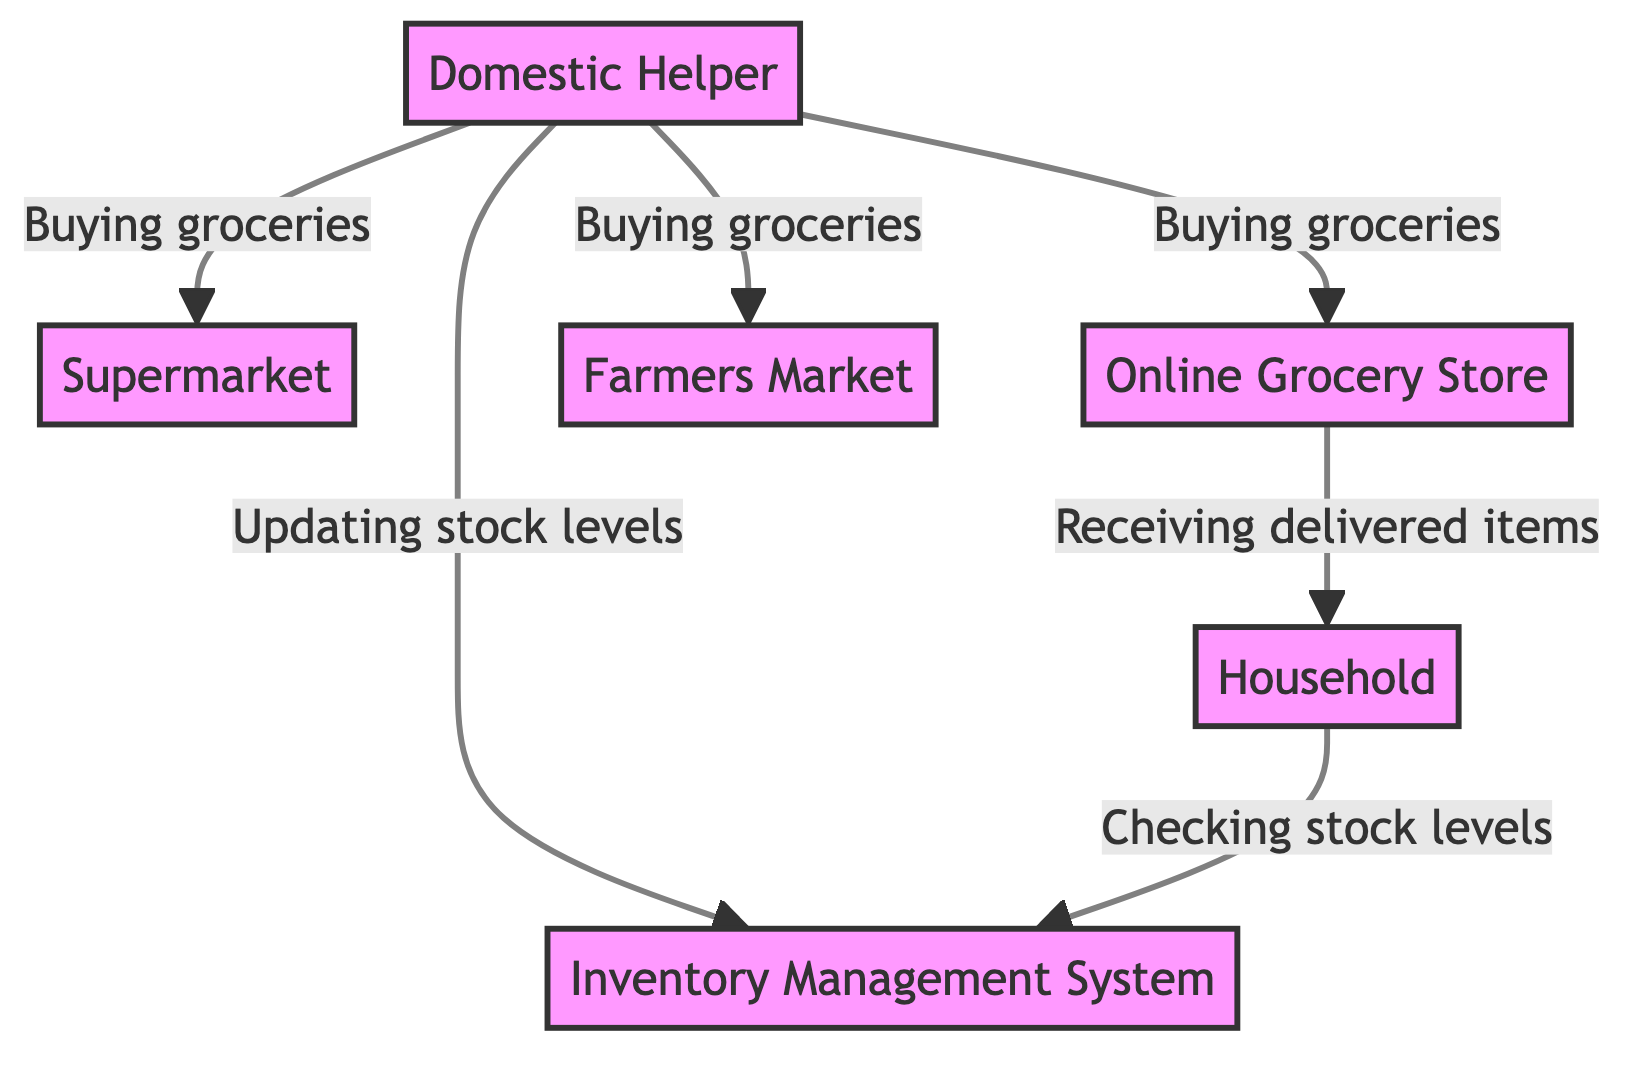What is the main role of the Domestic Helper? The Domestic Helper's role is defined as "Inventory Manager, Shopper" in the diagram, indicating their primary responsibilities.
Answer: Inventory Manager, Shopper How many sources is the Domestic Helper purchasing groceries from? The diagram shows three sources of grocery items where the Domestic Helper is involved in purchasing: Supermarket, Online Grocery Store, and Farmers Market.
Answer: Three Which tool is used to track household grocery inventory? In the diagram, the tool referred to for tracking household grocery inventory is named "Pantry Tracker App", explicitly stated in the attributes of the Inventory Management System.
Answer: Pantry Tracker App What is the interaction type between the Online Grocery Store and Household? According to the edges in the diagram, the interaction type between the Online Grocery Store and the Household is "Receiving delivered items", indicating the nature of their connection.
Answer: Receiving delivered items What does the Household do to manage its inventory? The Household checks stock levels in the Inventory Management System, as indicated by the edge connecting them in the diagram with the interaction labeled "Checking stock levels".
Answer: Checking stock levels What is the trust level of the Domestic Helper? The diagram describes the Domestic Helper's trust level as "High", which reflects the reliability placed on them for grocery management.
Answer: High From which node does the Domestic Helper update stock levels? The Domestic Helper updates stock levels in the Inventory Management System, which is shown in the diagram as the connection between these two nodes with the interaction labeled "Updating stock levels".
Answer: Inventory Management System How many nodes are involved in the purchasing process? The purchasing process involves four nodes: Domestic Helper, Supermarket, Online Grocery Store, and Farmers Market, indicating all components that participate in this buying interaction.
Answer: Four What is the primary source of grocery items? The primary source of grocery items is noted as "Local Supermarket" in the description of the Supermarket node, emphasizing its main role in the supply chain.
Answer: Local Supermarket 